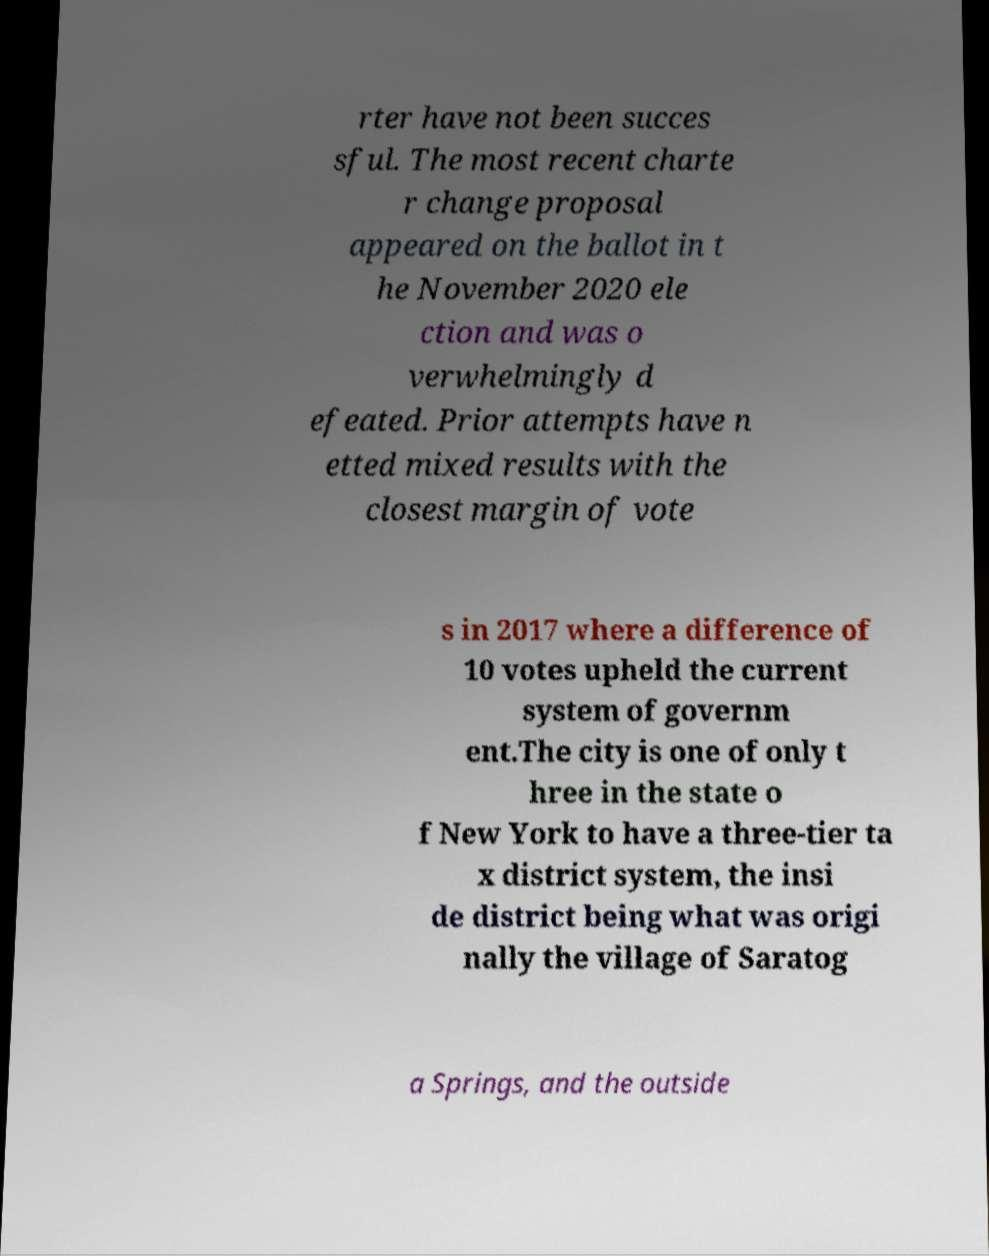Can you read and provide the text displayed in the image?This photo seems to have some interesting text. Can you extract and type it out for me? rter have not been succes sful. The most recent charte r change proposal appeared on the ballot in t he November 2020 ele ction and was o verwhelmingly d efeated. Prior attempts have n etted mixed results with the closest margin of vote s in 2017 where a difference of 10 votes upheld the current system of governm ent.The city is one of only t hree in the state o f New York to have a three-tier ta x district system, the insi de district being what was origi nally the village of Saratog a Springs, and the outside 